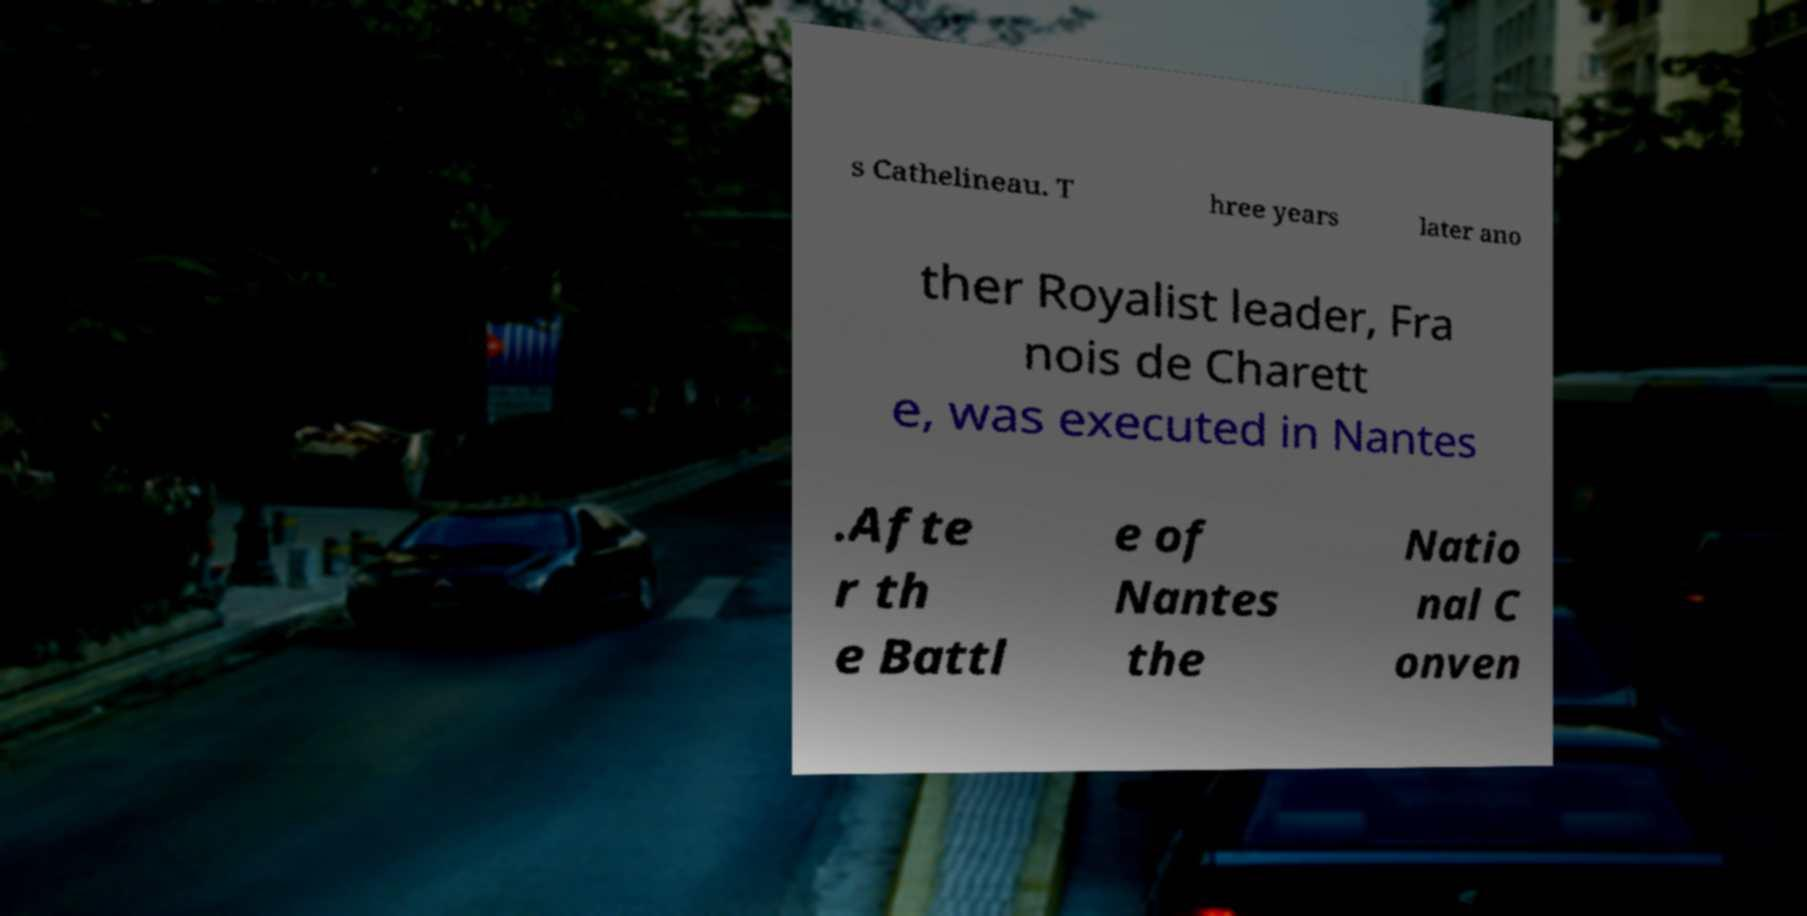There's text embedded in this image that I need extracted. Can you transcribe it verbatim? s Cathelineau. T hree years later ano ther Royalist leader, Fra nois de Charett e, was executed in Nantes .Afte r th e Battl e of Nantes the Natio nal C onven 